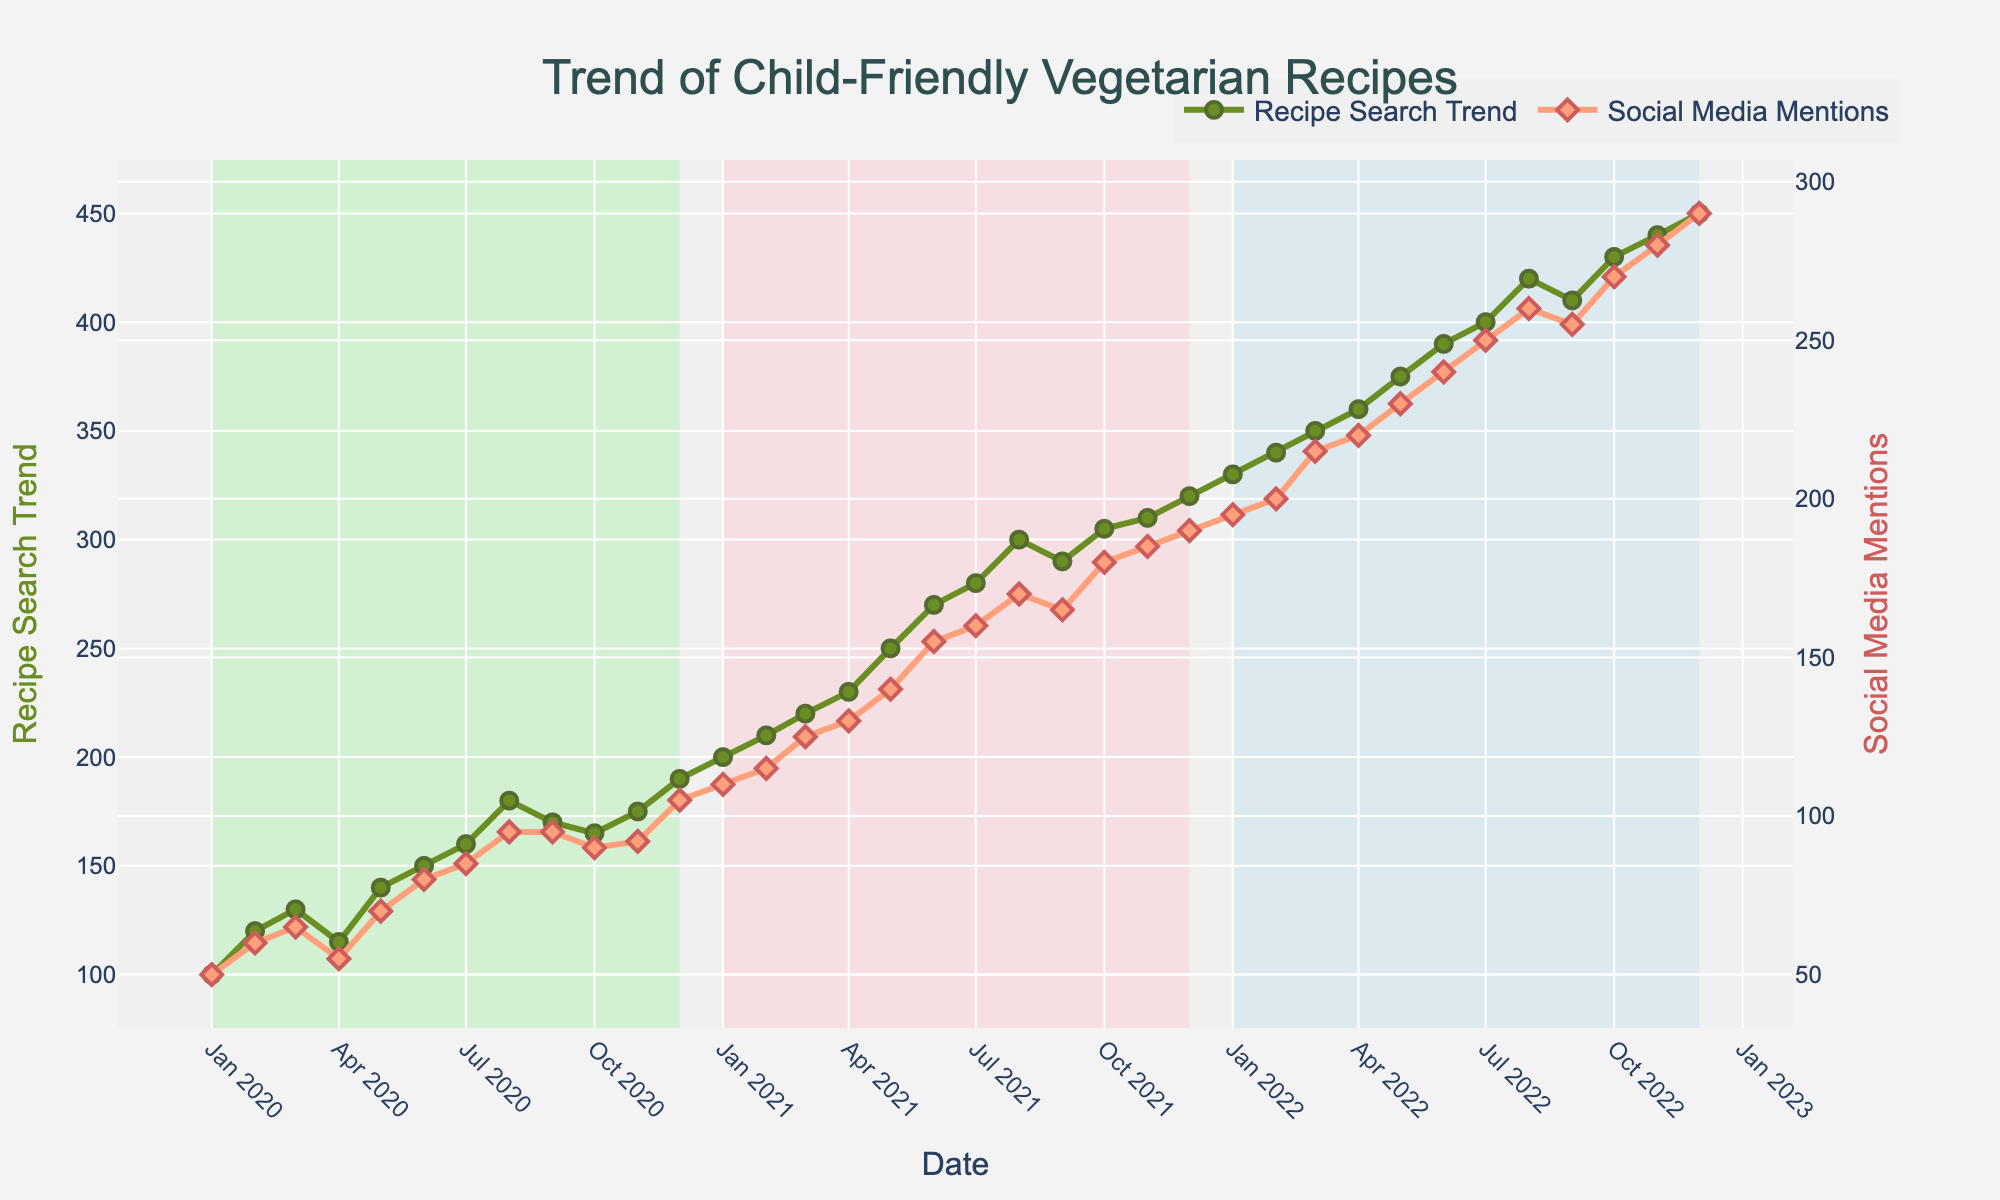What is the title of the plot? The title can be found at the top center of the figure. The plot's title is written in a slightly larger, bold font. It says "Trend of Child-Friendly Vegetarian Recipes".
Answer: Trend of Child-Friendly Vegetarian Recipes What does the y-axis on the left represent? The left y-axis title dictates what it represents. It's labeled "Recipe Search Trend".
Answer: Recipe Search Trend Which color line represents social media mentions? Look for the color associated with the "Social Media Mentions" in the legend. It's represented by a salmon-colored (pinkish-red) line.
Answer: Salmon How did the social media mentions trend in December 2022 compare to January 2020? Locate the social media mentions for both dates on the right y-axis. Social media mentions were 50 in January 2020 and 290 in December 2022.
Answer: Increased What was the highest value for recipe search trends and when did it occur? Look for the peak value on the green line (recipe search trends). The highest value is 450, occurring in December 2022.
Answer: 450, December 2022 How much did social media mentions increase from January 2021 to January 2022? Locate the values for social media mentions on the right y-axis for the dates January 2021 and January 2022. Subtract January 2021’s value (110) from January 2022’s value (195). The increase is 85.
Answer: 85 Was there any month when the recipe search trend decreased compared to the previous month? If so, when? Look at the green line (recipe search trends) for any downward slopes. April 2020 shows a decrease from 130 in March 2020 to 115 in April 2020.
Answer: Yes, April 2020 Which year saw the highest increase in social media mentions? Compare the yearly increases by looking at the end-of-year values. The greatest increase from the previous year occurs from December 2021 (190) to December 2022 (290), an increase of 100.
Answer: 2022 By how much did the average monthly recipe search trend increase from 2020 to 2021? Calculate the average search trend for each year. For 2020: (100+120+130+115+140+150+160+180+170+165+175+190)/12 = 149.17. For 2021: (200+210+220+230+250+270+280+300+290+305+310+320)/12 = 256.67. The increase is 256.67 - 149.17, which is approximately 107.50.
Answer: 107.50 